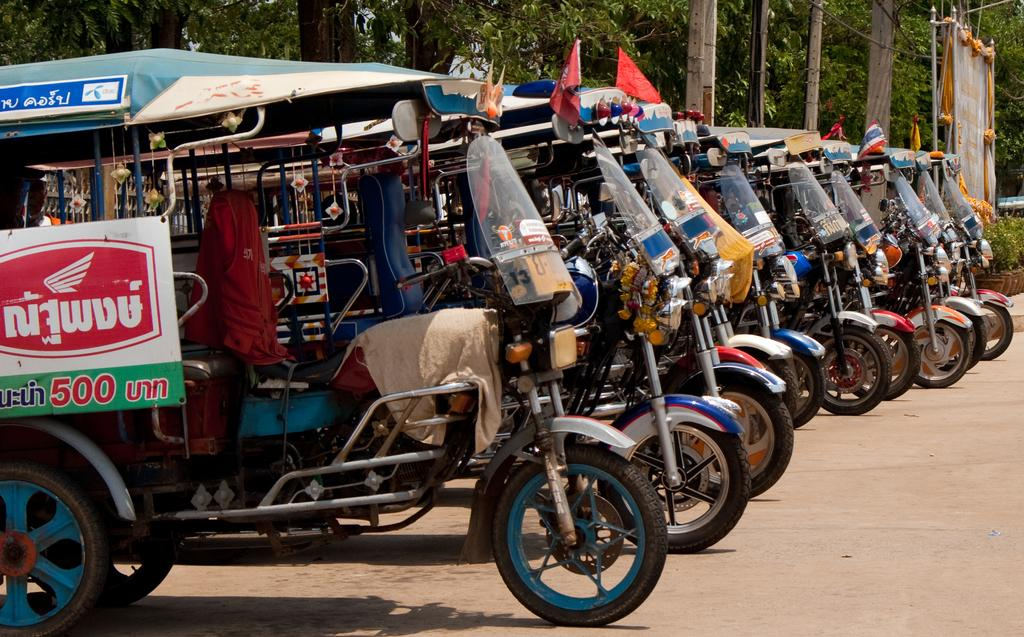What types of objects are present in the image? There are many colorful vehicles in the image. Can you describe any specific features of these vehicles? One of the vehicles has a board on it. What can be seen in the background of the image? There are many trees visible in the background of the image. How many pigs are sitting on the board of the vehicle in the image? There are no pigs present in the image. What sound does the bell make when it is rung in the image? There is no bell present in the image. 